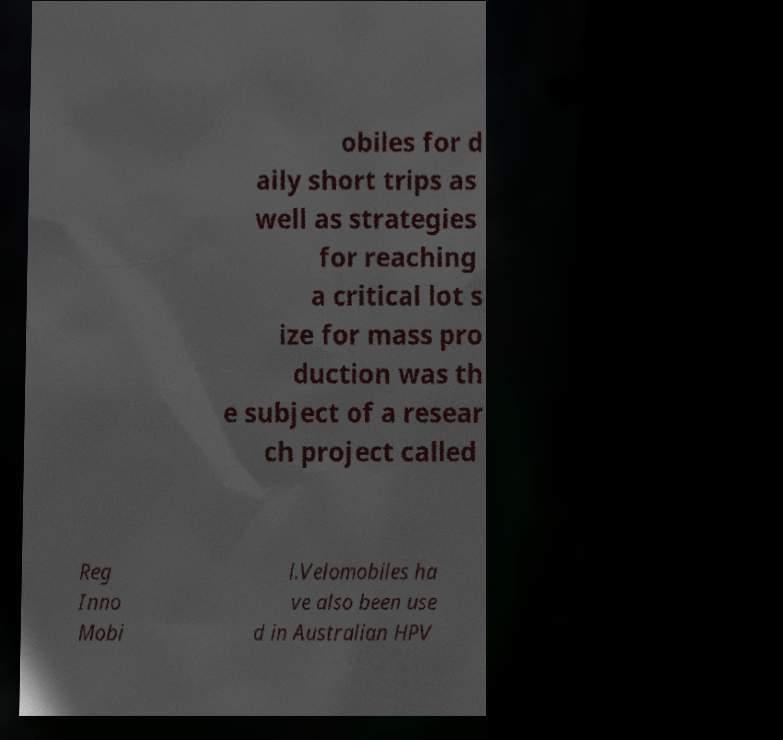Could you extract and type out the text from this image? obiles for d aily short trips as well as strategies for reaching a critical lot s ize for mass pro duction was th e subject of a resear ch project called Reg Inno Mobi l.Velomobiles ha ve also been use d in Australian HPV 